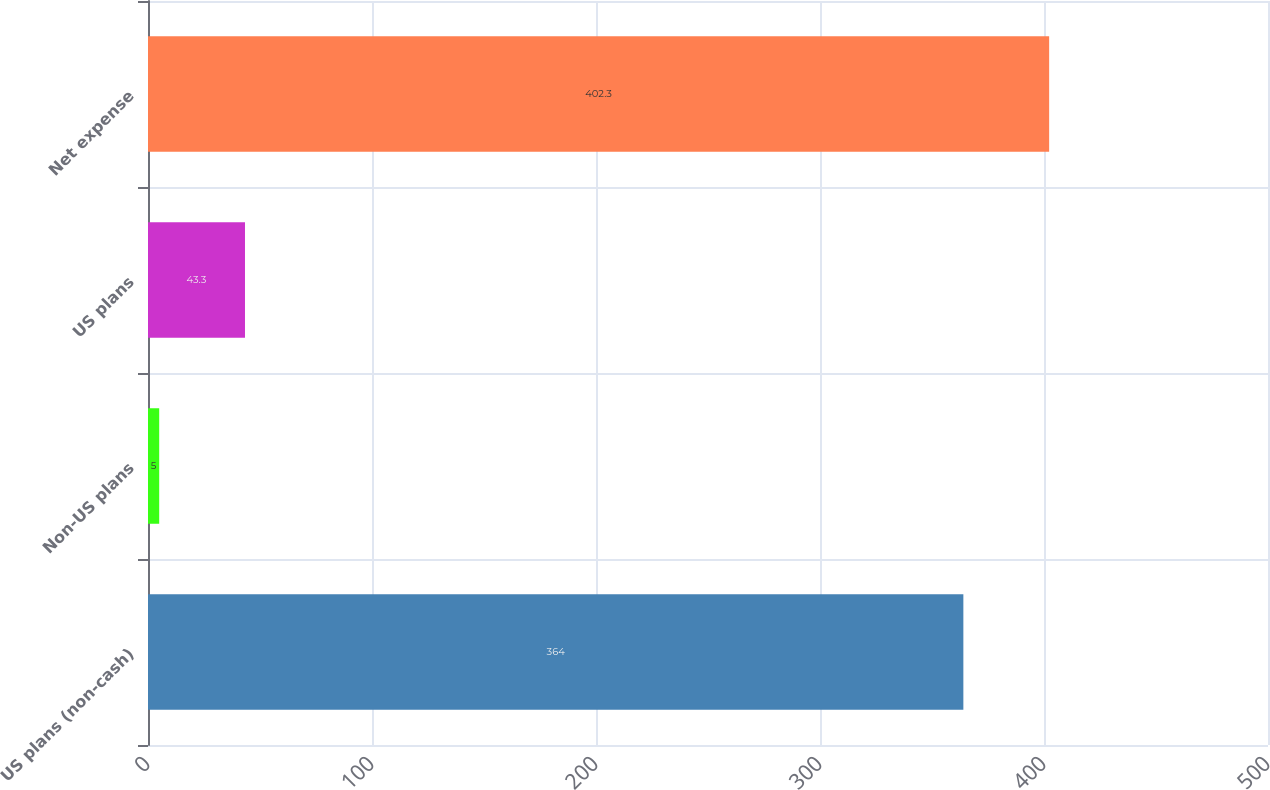<chart> <loc_0><loc_0><loc_500><loc_500><bar_chart><fcel>US plans (non-cash)<fcel>Non-US plans<fcel>US plans<fcel>Net expense<nl><fcel>364<fcel>5<fcel>43.3<fcel>402.3<nl></chart> 